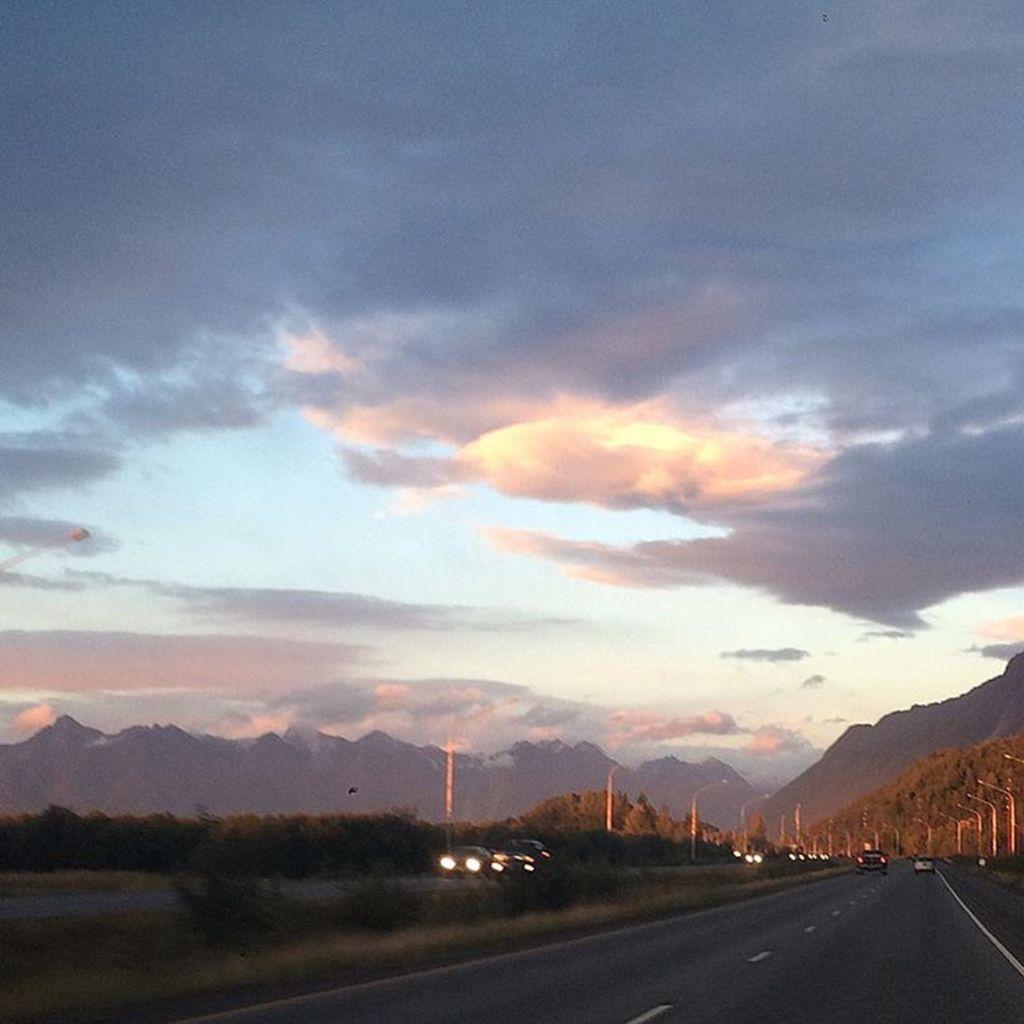Can you describe this image briefly? In this picture we can observe a road. There are some vehicles moving on this road. On the divider there are some plants. We can observe some poles on either sides of the road. There are some trees. In the background there are hills and a sky with clouds. 